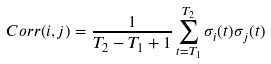Convert formula to latex. <formula><loc_0><loc_0><loc_500><loc_500>C o r r ( i , j ) = \frac { 1 } { T _ { 2 } - T _ { 1 } + 1 } \sum _ { t = T _ { 1 } } ^ { T _ { 2 } } \sigma _ { i } ( t ) \sigma _ { j } ( t )</formula> 